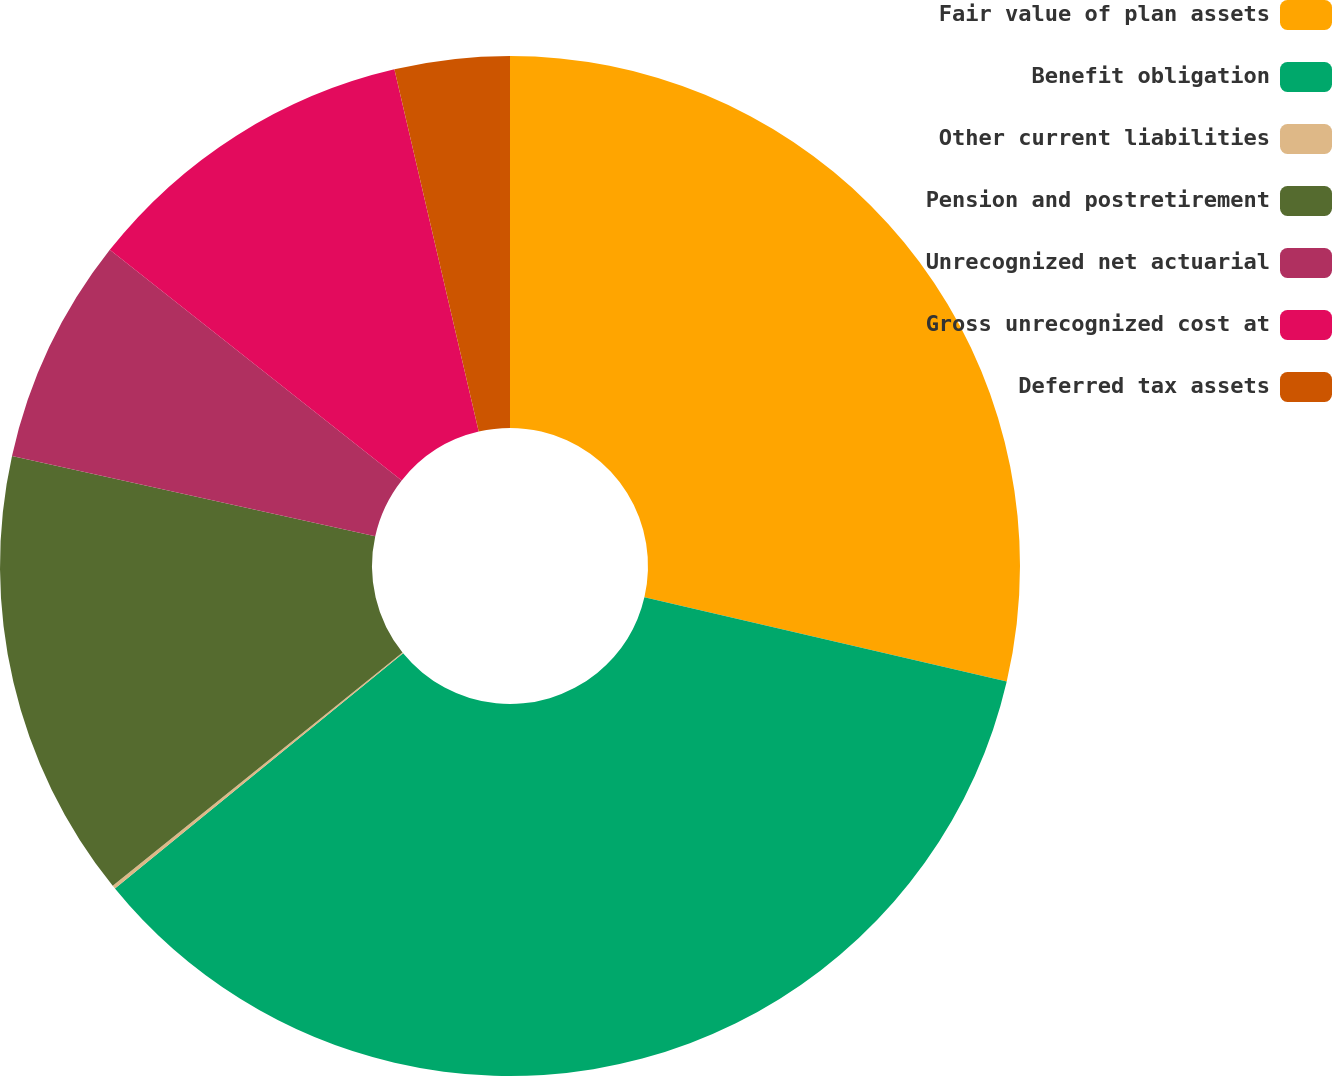Convert chart. <chart><loc_0><loc_0><loc_500><loc_500><pie_chart><fcel>Fair value of plan assets<fcel>Benefit obligation<fcel>Other current liabilities<fcel>Pension and postretirement<fcel>Unrecognized net actuarial<fcel>Gross unrecognized cost at<fcel>Deferred tax assets<nl><fcel>28.64%<fcel>35.47%<fcel>0.11%<fcel>14.25%<fcel>7.18%<fcel>10.72%<fcel>3.64%<nl></chart> 